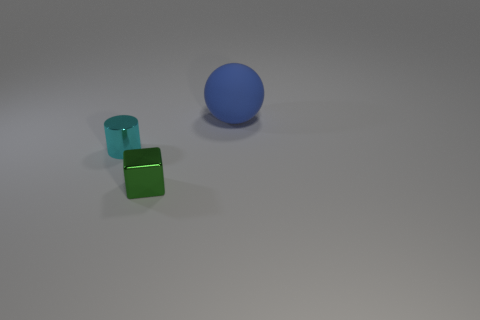Add 2 big cyan metal blocks. How many objects exist? 5 Subtract all balls. How many objects are left? 2 Add 3 tiny gray things. How many tiny gray things exist? 3 Subtract 0 green cylinders. How many objects are left? 3 Subtract all gray spheres. Subtract all tiny cyan objects. How many objects are left? 2 Add 1 metal objects. How many metal objects are left? 3 